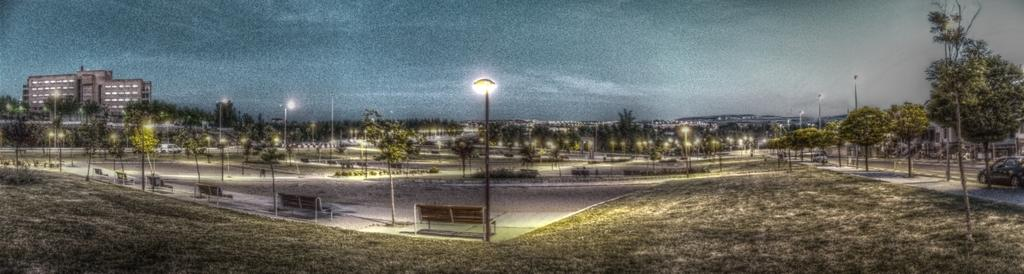What type of natural elements can be seen in the image? There are trees in the image. What type of artificial elements can be seen in the image? There are lights, poles, benches, vehicles, buildings, and roads visible in the image. What part of the natural environment is visible in the image? The sky is visible at the top of the image, and the ground is visible at the bottom of the image. Can you tell me how many friends are sitting on the benches in the image? There is no information about friends in the image; it only shows trees, lights, poles, benches, vehicles, buildings, and the sky. 